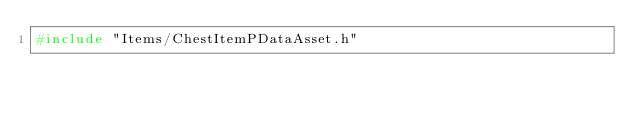Convert code to text. <code><loc_0><loc_0><loc_500><loc_500><_C++_>#include "Items/ChestItemPDataAsset.h"</code> 